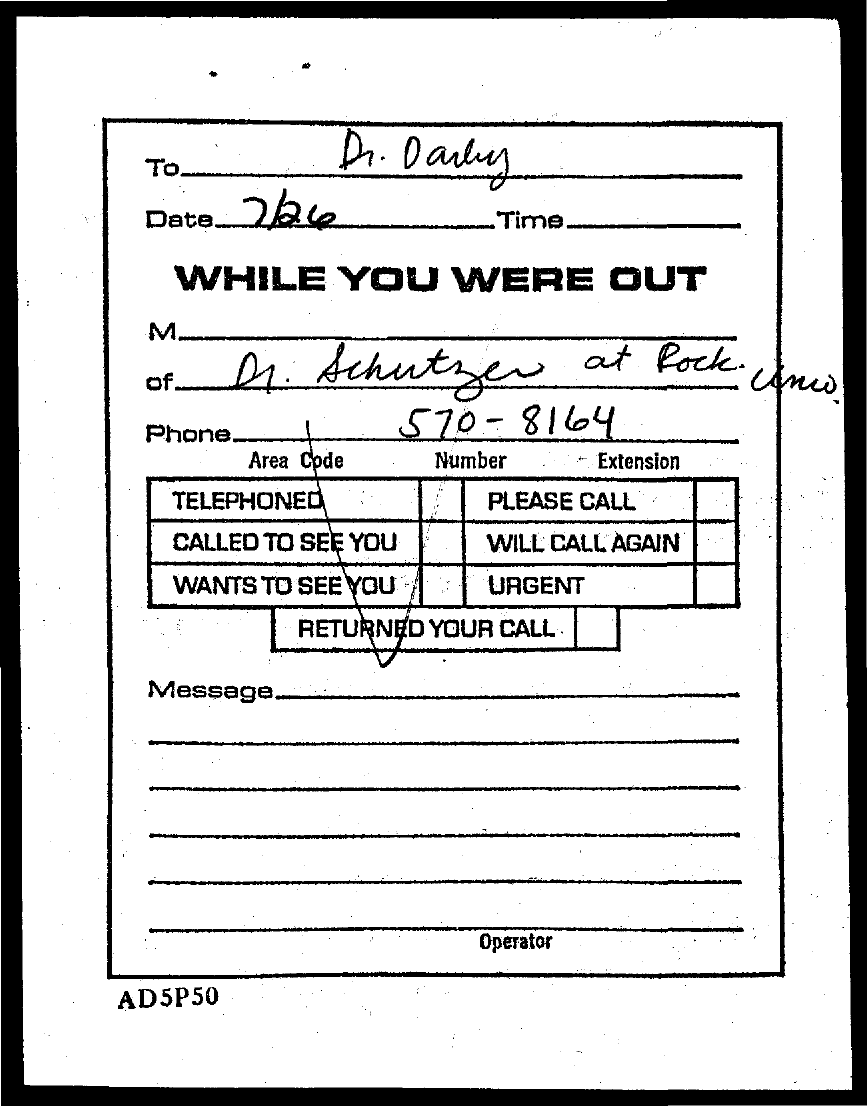Indicate a few pertinent items in this graphic. The phone number mentioned in this document is 570-8164. The person to whom the document is addressed is Dr. Darby. The date mentioned in this document is July 26th. 